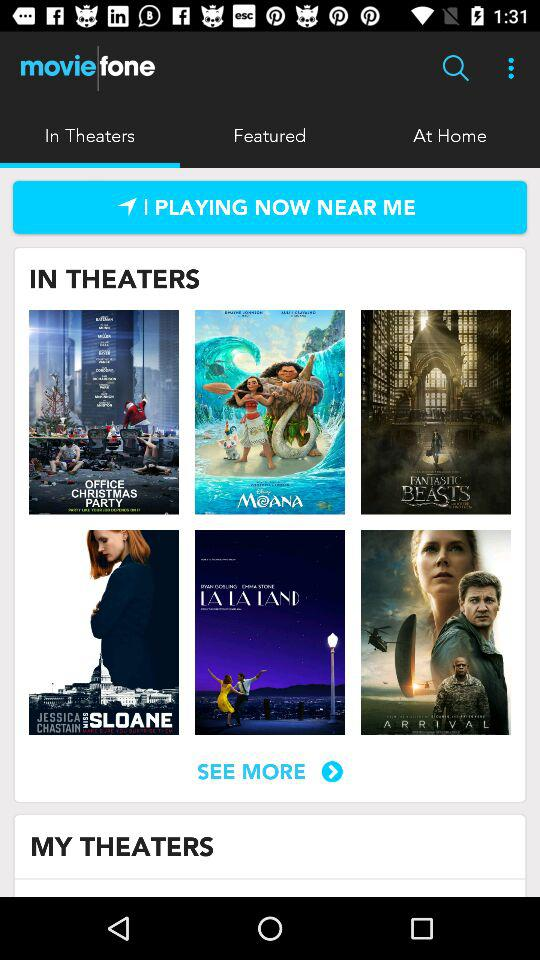When is the next showing of "Moana"?
When the provided information is insufficient, respond with <no answer>. <no answer> 